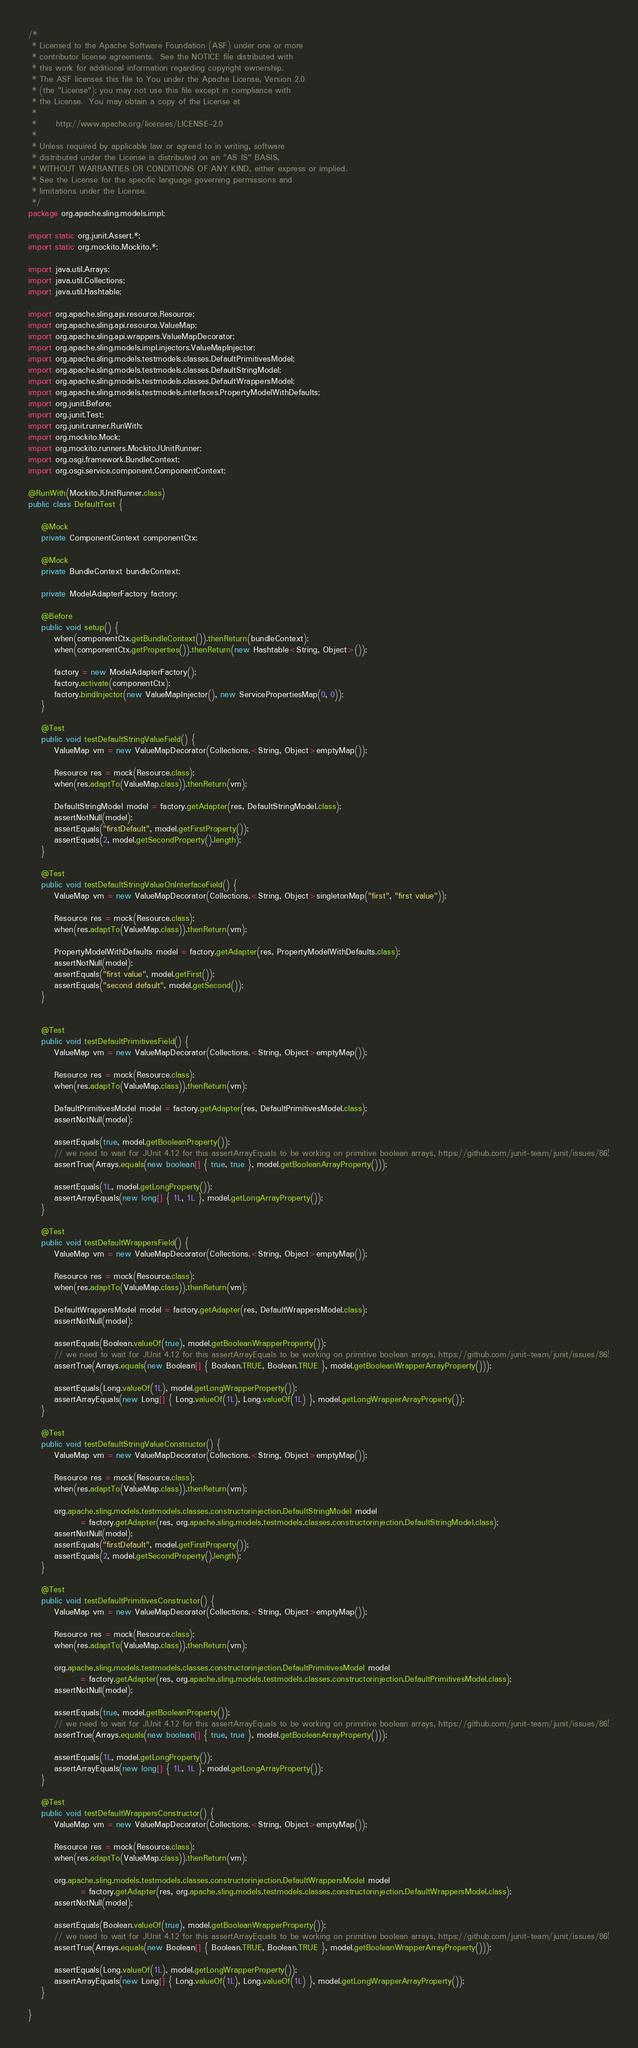<code> <loc_0><loc_0><loc_500><loc_500><_Java_>/*
 * Licensed to the Apache Software Foundation (ASF) under one or more
 * contributor license agreements.  See the NOTICE file distributed with
 * this work for additional information regarding copyright ownership.
 * The ASF licenses this file to You under the Apache License, Version 2.0
 * (the "License"); you may not use this file except in compliance with
 * the License.  You may obtain a copy of the License at
 *
 *      http://www.apache.org/licenses/LICENSE-2.0
 *
 * Unless required by applicable law or agreed to in writing, software
 * distributed under the License is distributed on an "AS IS" BASIS,
 * WITHOUT WARRANTIES OR CONDITIONS OF ANY KIND, either express or implied.
 * See the License for the specific language governing permissions and
 * limitations under the License.
 */
package org.apache.sling.models.impl;

import static org.junit.Assert.*;
import static org.mockito.Mockito.*;

import java.util.Arrays;
import java.util.Collections;
import java.util.Hashtable;

import org.apache.sling.api.resource.Resource;
import org.apache.sling.api.resource.ValueMap;
import org.apache.sling.api.wrappers.ValueMapDecorator;
import org.apache.sling.models.impl.injectors.ValueMapInjector;
import org.apache.sling.models.testmodels.classes.DefaultPrimitivesModel;
import org.apache.sling.models.testmodels.classes.DefaultStringModel;
import org.apache.sling.models.testmodels.classes.DefaultWrappersModel;
import org.apache.sling.models.testmodels.interfaces.PropertyModelWithDefaults;
import org.junit.Before;
import org.junit.Test;
import org.junit.runner.RunWith;
import org.mockito.Mock;
import org.mockito.runners.MockitoJUnitRunner;
import org.osgi.framework.BundleContext;
import org.osgi.service.component.ComponentContext;

@RunWith(MockitoJUnitRunner.class)
public class DefaultTest {

    @Mock
    private ComponentContext componentCtx;

    @Mock
    private BundleContext bundleContext;

    private ModelAdapterFactory factory;

    @Before
    public void setup() {
        when(componentCtx.getBundleContext()).thenReturn(bundleContext);
        when(componentCtx.getProperties()).thenReturn(new Hashtable<String, Object>());

        factory = new ModelAdapterFactory();
        factory.activate(componentCtx);
        factory.bindInjector(new ValueMapInjector(), new ServicePropertiesMap(0, 0));
    }

    @Test
    public void testDefaultStringValueField() {
        ValueMap vm = new ValueMapDecorator(Collections.<String, Object>emptyMap());

        Resource res = mock(Resource.class);
        when(res.adaptTo(ValueMap.class)).thenReturn(vm);

        DefaultStringModel model = factory.getAdapter(res, DefaultStringModel.class);
        assertNotNull(model);
        assertEquals("firstDefault", model.getFirstProperty());
        assertEquals(2, model.getSecondProperty().length);
    }

    @Test
    public void testDefaultStringValueOnInterfaceField() {
        ValueMap vm = new ValueMapDecorator(Collections.<String, Object>singletonMap("first", "first value"));

        Resource res = mock(Resource.class);
        when(res.adaptTo(ValueMap.class)).thenReturn(vm);

        PropertyModelWithDefaults model = factory.getAdapter(res, PropertyModelWithDefaults.class);
        assertNotNull(model);
        assertEquals("first value", model.getFirst());
        assertEquals("second default", model.getSecond());
    }


    @Test
    public void testDefaultPrimitivesField() {
        ValueMap vm = new ValueMapDecorator(Collections.<String, Object>emptyMap());

        Resource res = mock(Resource.class);
        when(res.adaptTo(ValueMap.class)).thenReturn(vm);

        DefaultPrimitivesModel model = factory.getAdapter(res, DefaultPrimitivesModel.class);
        assertNotNull(model);

        assertEquals(true, model.getBooleanProperty());
        // we need to wait for JUnit 4.12 for this assertArrayEquals to be working on primitive boolean arrays, https://github.com/junit-team/junit/issues/86!
        assertTrue(Arrays.equals(new boolean[] { true, true }, model.getBooleanArrayProperty()));

        assertEquals(1L, model.getLongProperty());
        assertArrayEquals(new long[] { 1L, 1L }, model.getLongArrayProperty());
    }

    @Test
    public void testDefaultWrappersField() {
        ValueMap vm = new ValueMapDecorator(Collections.<String, Object>emptyMap());

        Resource res = mock(Resource.class);
        when(res.adaptTo(ValueMap.class)).thenReturn(vm);

        DefaultWrappersModel model = factory.getAdapter(res, DefaultWrappersModel.class);
        assertNotNull(model);

        assertEquals(Boolean.valueOf(true), model.getBooleanWrapperProperty());
        // we need to wait for JUnit 4.12 for this assertArrayEquals to be working on primitive boolean arrays, https://github.com/junit-team/junit/issues/86!
        assertTrue(Arrays.equals(new Boolean[] { Boolean.TRUE, Boolean.TRUE }, model.getBooleanWrapperArrayProperty()));

        assertEquals(Long.valueOf(1L), model.getLongWrapperProperty());
        assertArrayEquals(new Long[] { Long.valueOf(1L), Long.valueOf(1L) }, model.getLongWrapperArrayProperty());
    }

    @Test
    public void testDefaultStringValueConstructor() {
        ValueMap vm = new ValueMapDecorator(Collections.<String, Object>emptyMap());

        Resource res = mock(Resource.class);
        when(res.adaptTo(ValueMap.class)).thenReturn(vm);

        org.apache.sling.models.testmodels.classes.constructorinjection.DefaultStringModel model
                = factory.getAdapter(res, org.apache.sling.models.testmodels.classes.constructorinjection.DefaultStringModel.class);
        assertNotNull(model);
        assertEquals("firstDefault", model.getFirstProperty());
        assertEquals(2, model.getSecondProperty().length);
    }

    @Test
    public void testDefaultPrimitivesConstructor() {
        ValueMap vm = new ValueMapDecorator(Collections.<String, Object>emptyMap());

        Resource res = mock(Resource.class);
        when(res.adaptTo(ValueMap.class)).thenReturn(vm);

        org.apache.sling.models.testmodels.classes.constructorinjection.DefaultPrimitivesModel model
                = factory.getAdapter(res, org.apache.sling.models.testmodels.classes.constructorinjection.DefaultPrimitivesModel.class);
        assertNotNull(model);

        assertEquals(true, model.getBooleanProperty());
        // we need to wait for JUnit 4.12 for this assertArrayEquals to be working on primitive boolean arrays, https://github.com/junit-team/junit/issues/86!
        assertTrue(Arrays.equals(new boolean[] { true, true }, model.getBooleanArrayProperty()));

        assertEquals(1L, model.getLongProperty());
        assertArrayEquals(new long[] { 1L, 1L }, model.getLongArrayProperty());
    }

    @Test
    public void testDefaultWrappersConstructor() {
        ValueMap vm = new ValueMapDecorator(Collections.<String, Object>emptyMap());

        Resource res = mock(Resource.class);
        when(res.adaptTo(ValueMap.class)).thenReturn(vm);

        org.apache.sling.models.testmodels.classes.constructorinjection.DefaultWrappersModel model
                = factory.getAdapter(res, org.apache.sling.models.testmodels.classes.constructorinjection.DefaultWrappersModel.class);
        assertNotNull(model);

        assertEquals(Boolean.valueOf(true), model.getBooleanWrapperProperty());
        // we need to wait for JUnit 4.12 for this assertArrayEquals to be working on primitive boolean arrays, https://github.com/junit-team/junit/issues/86!
        assertTrue(Arrays.equals(new Boolean[] { Boolean.TRUE, Boolean.TRUE }, model.getBooleanWrapperArrayProperty()));

        assertEquals(Long.valueOf(1L), model.getLongWrapperProperty());
        assertArrayEquals(new Long[] { Long.valueOf(1L), Long.valueOf(1L) }, model.getLongWrapperArrayProperty());
    }

}
</code> 